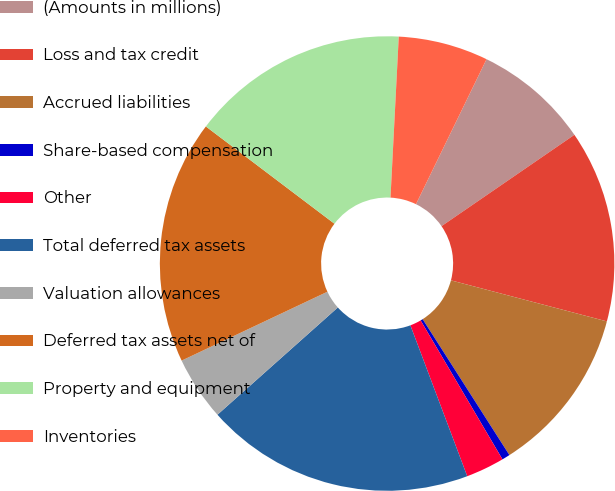Convert chart. <chart><loc_0><loc_0><loc_500><loc_500><pie_chart><fcel>(Amounts in millions)<fcel>Loss and tax credit<fcel>Accrued liabilities<fcel>Share-based compensation<fcel>Other<fcel>Total deferred tax assets<fcel>Valuation allowances<fcel>Deferred tax assets net of<fcel>Property and equipment<fcel>Inventories<nl><fcel>8.21%<fcel>13.68%<fcel>11.86%<fcel>0.57%<fcel>2.74%<fcel>19.15%<fcel>4.56%<fcel>17.33%<fcel>15.51%<fcel>6.39%<nl></chart> 